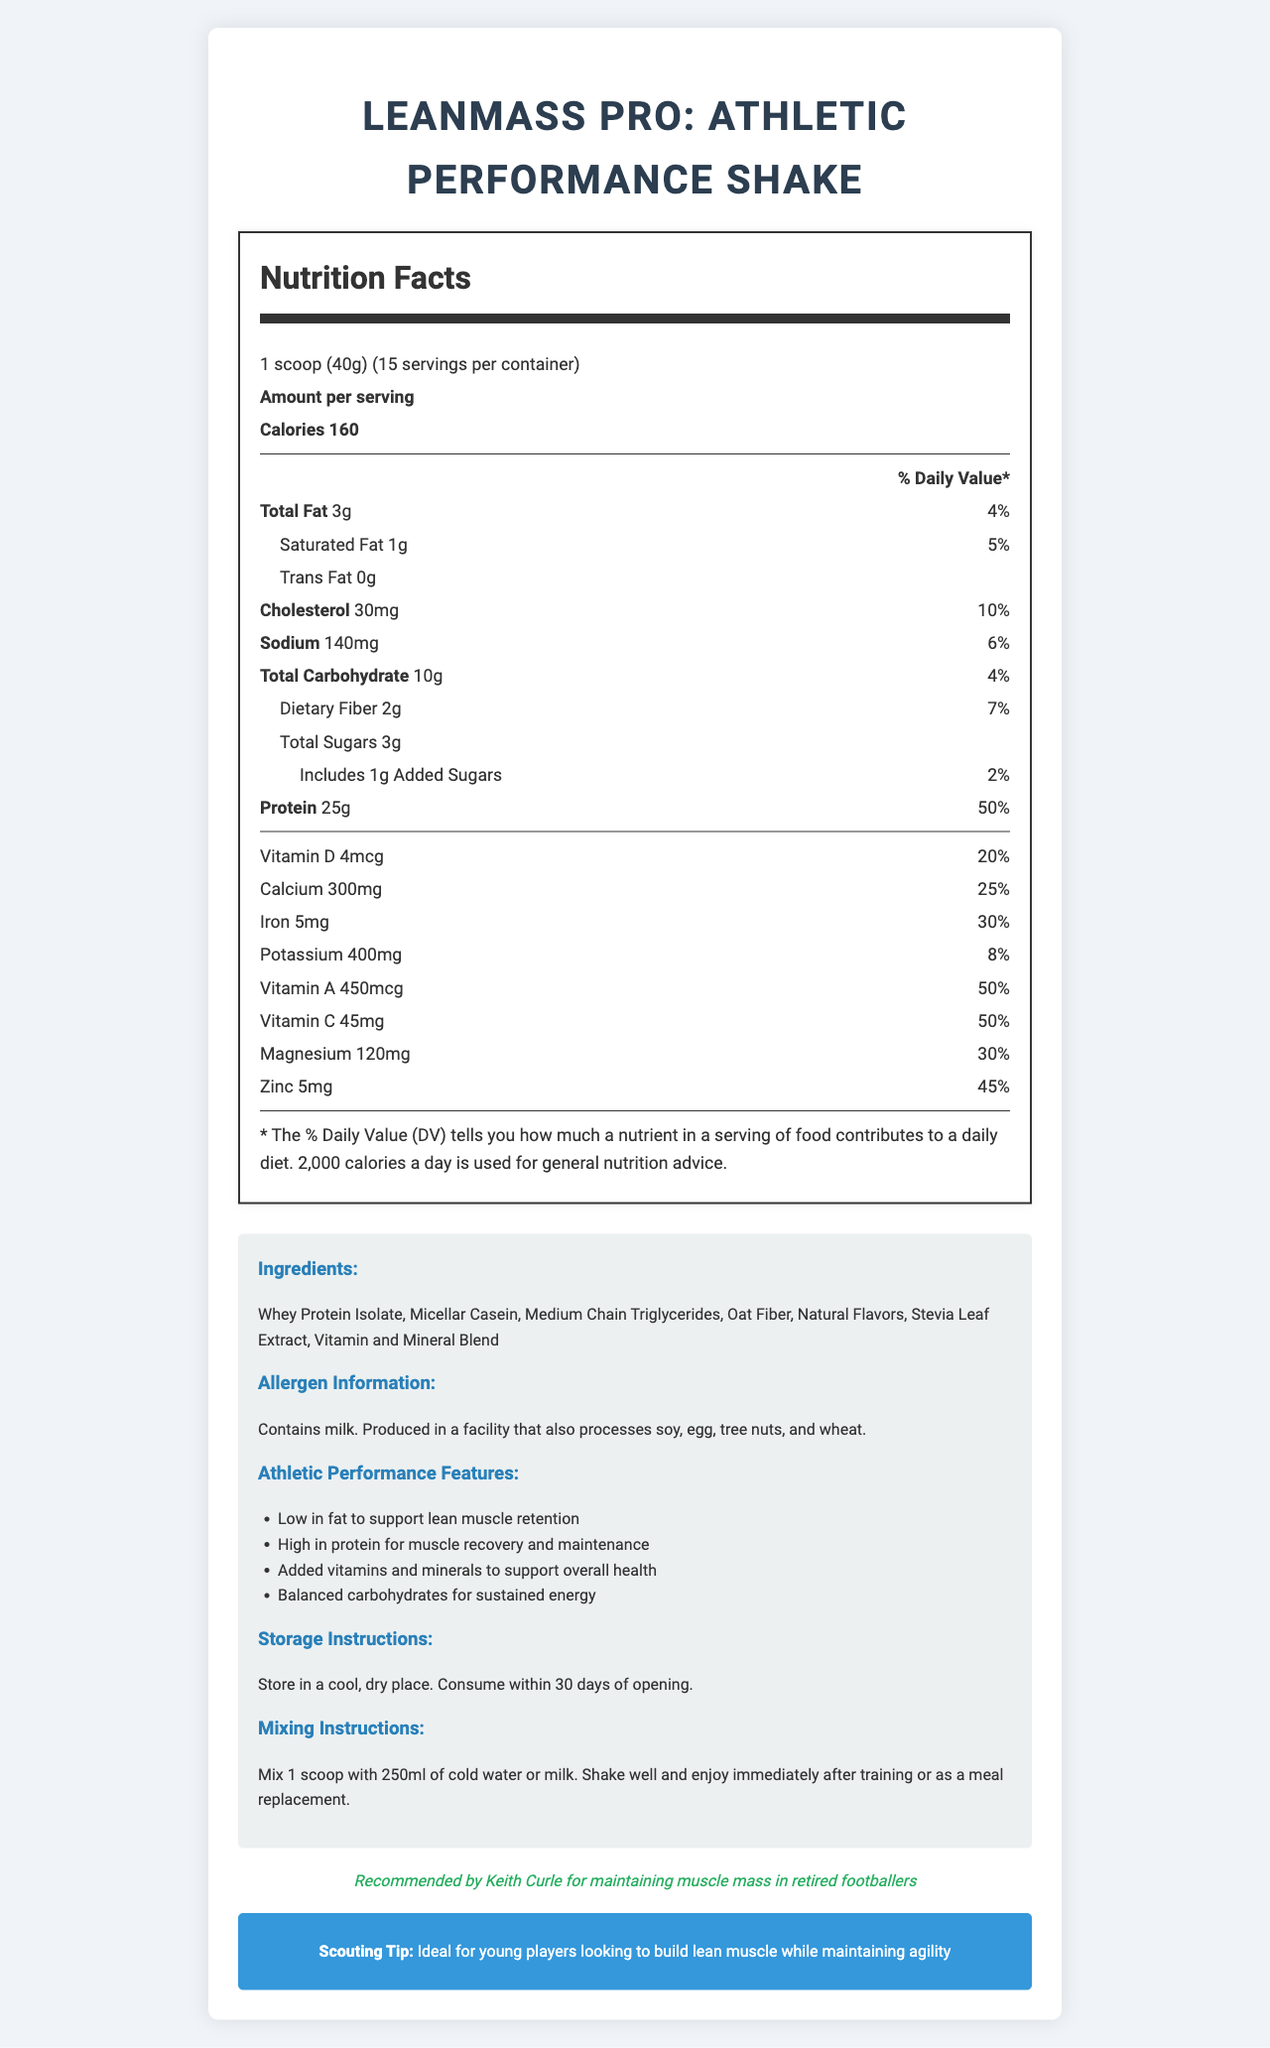What is the serving size of the LeanMass Pro shake? The serving size is specified in the document as "1 scoop (40g)".
Answer: 1 scoop (40g) How many total servings are there per container? The document states that there are 15 servings per container.
Answer: 15 servings How many grams of protein does each serving contain? The document lists the amount of protein per serving as 25g.
Answer: 25g What percentage of the daily value of calcium is provided by each serving? The document shows that each serving provides 25% of the daily value of calcium.
Answer: 25% Which ingredient in the shake is a source of dietary fiber? The ingredient oat fiber is listed, which is known to be a source of dietary fiber.
Answer: Oat Fiber How much cholesterol is in each serving? The document lists the amount of cholesterol per serving as 30mg.
Answer: 30mg Which of the following is not an ingredient in the LeanMass Pro shake? 
A. Whey Protein Isolate 
B. Soy Protein 
C. Stevia Leaf Extract 
D. Oat Fiber The document lists "Whey Protein Isolate", "Stevia Leaf Extract", and "Oat Fiber" as ingredients, but not "Soy Protein".
Answer: B What is the percentage of daily value for iron provided per serving? 
A. 10% 
B. 20% 
C. 30% 
D. 40% The document states that the percentage of daily value for iron per serving is 30%.
Answer: C Is the shake suitable for someone with a milk allergy? The document includes allergen information stating the product contains milk.
Answer: No Summarize the main features of the LeanMass Pro shake. The explanation summarizes the document by highlighting key features such as nutritional content, ingredients, endorsements, and specific details provided in the document.
Answer: The LeanMass Pro: Athletic Performance Shake is a low-fat, nutrient-dense meal replacement shake designed for maintaining lean muscle mass in retired athletes. Each 40g serving provides 160 calories, 3g of total fat, 25g of protein, and a variety of vitamins and minerals. The shake contains whey protein isolate, micellar casein, and medium chain triglycerides, among other ingredients. It is endorsed by Keith Curle and is recommended for maintaining muscle mass in retired footballers. The product also includes additional athletic performance features and storage and mixing instructions. What is the recommended storage instruction for LeanMass Pro? The document specifies to store the product in a cool, dry place and consume it within 30 days of opening.
Answer: Store in a cool, dry place. Consume within 30 days of opening. How much vitamin D does each serving contain? The document states that each serving contains 4mcg of vitamin D.
Answer: 4mcg Can this document tell me if the product is gluten-free? The document provides allergen information but does not specify whether the product is gluten-free.
Answer: Not enough information Does the LeanMass Pro shake include any added sugars? The document indicates that each serving includes 1g of added sugars.
Answer: Yes What is Keith Curle's endorsement of the product? The document includes an endorsement by Keith Curle suggesting the product is recommended for maintaining muscle mass in retired footballers.
Answer: Recommended by Keith Curle for maintaining muscle mass in retired footballers Is there any fiber in the LeanMass Pro shake? The document shows that each serving contains 2g of dietary fiber.
Answer: Yes 